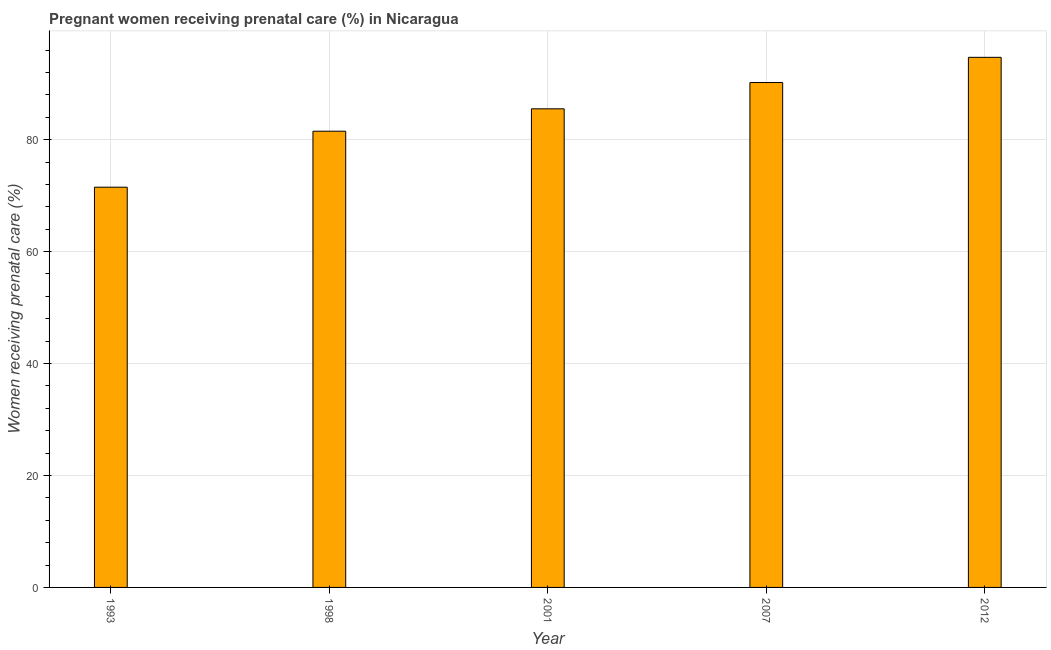What is the title of the graph?
Give a very brief answer. Pregnant women receiving prenatal care (%) in Nicaragua. What is the label or title of the Y-axis?
Provide a succinct answer. Women receiving prenatal care (%). What is the percentage of pregnant women receiving prenatal care in 2001?
Ensure brevity in your answer.  85.5. Across all years, what is the maximum percentage of pregnant women receiving prenatal care?
Make the answer very short. 94.7. Across all years, what is the minimum percentage of pregnant women receiving prenatal care?
Provide a short and direct response. 71.5. In which year was the percentage of pregnant women receiving prenatal care maximum?
Provide a short and direct response. 2012. In which year was the percentage of pregnant women receiving prenatal care minimum?
Offer a very short reply. 1993. What is the sum of the percentage of pregnant women receiving prenatal care?
Offer a terse response. 423.4. What is the average percentage of pregnant women receiving prenatal care per year?
Your answer should be very brief. 84.68. What is the median percentage of pregnant women receiving prenatal care?
Keep it short and to the point. 85.5. In how many years, is the percentage of pregnant women receiving prenatal care greater than 68 %?
Make the answer very short. 5. What is the ratio of the percentage of pregnant women receiving prenatal care in 1998 to that in 2001?
Offer a terse response. 0.95. Is the difference between the percentage of pregnant women receiving prenatal care in 1993 and 2012 greater than the difference between any two years?
Your response must be concise. Yes. What is the difference between the highest and the second highest percentage of pregnant women receiving prenatal care?
Your response must be concise. 4.5. Is the sum of the percentage of pregnant women receiving prenatal care in 1993 and 1998 greater than the maximum percentage of pregnant women receiving prenatal care across all years?
Ensure brevity in your answer.  Yes. What is the difference between the highest and the lowest percentage of pregnant women receiving prenatal care?
Make the answer very short. 23.2. In how many years, is the percentage of pregnant women receiving prenatal care greater than the average percentage of pregnant women receiving prenatal care taken over all years?
Offer a terse response. 3. How many bars are there?
Give a very brief answer. 5. Are the values on the major ticks of Y-axis written in scientific E-notation?
Ensure brevity in your answer.  No. What is the Women receiving prenatal care (%) in 1993?
Give a very brief answer. 71.5. What is the Women receiving prenatal care (%) in 1998?
Your answer should be compact. 81.5. What is the Women receiving prenatal care (%) of 2001?
Provide a succinct answer. 85.5. What is the Women receiving prenatal care (%) of 2007?
Make the answer very short. 90.2. What is the Women receiving prenatal care (%) of 2012?
Provide a succinct answer. 94.7. What is the difference between the Women receiving prenatal care (%) in 1993 and 1998?
Keep it short and to the point. -10. What is the difference between the Women receiving prenatal care (%) in 1993 and 2001?
Your response must be concise. -14. What is the difference between the Women receiving prenatal care (%) in 1993 and 2007?
Provide a short and direct response. -18.7. What is the difference between the Women receiving prenatal care (%) in 1993 and 2012?
Provide a succinct answer. -23.2. What is the difference between the Women receiving prenatal care (%) in 1998 and 2012?
Ensure brevity in your answer.  -13.2. What is the difference between the Women receiving prenatal care (%) in 2001 and 2007?
Provide a succinct answer. -4.7. What is the ratio of the Women receiving prenatal care (%) in 1993 to that in 1998?
Offer a very short reply. 0.88. What is the ratio of the Women receiving prenatal care (%) in 1993 to that in 2001?
Offer a terse response. 0.84. What is the ratio of the Women receiving prenatal care (%) in 1993 to that in 2007?
Give a very brief answer. 0.79. What is the ratio of the Women receiving prenatal care (%) in 1993 to that in 2012?
Your answer should be compact. 0.76. What is the ratio of the Women receiving prenatal care (%) in 1998 to that in 2001?
Offer a very short reply. 0.95. What is the ratio of the Women receiving prenatal care (%) in 1998 to that in 2007?
Make the answer very short. 0.9. What is the ratio of the Women receiving prenatal care (%) in 1998 to that in 2012?
Make the answer very short. 0.86. What is the ratio of the Women receiving prenatal care (%) in 2001 to that in 2007?
Offer a very short reply. 0.95. What is the ratio of the Women receiving prenatal care (%) in 2001 to that in 2012?
Ensure brevity in your answer.  0.9. 